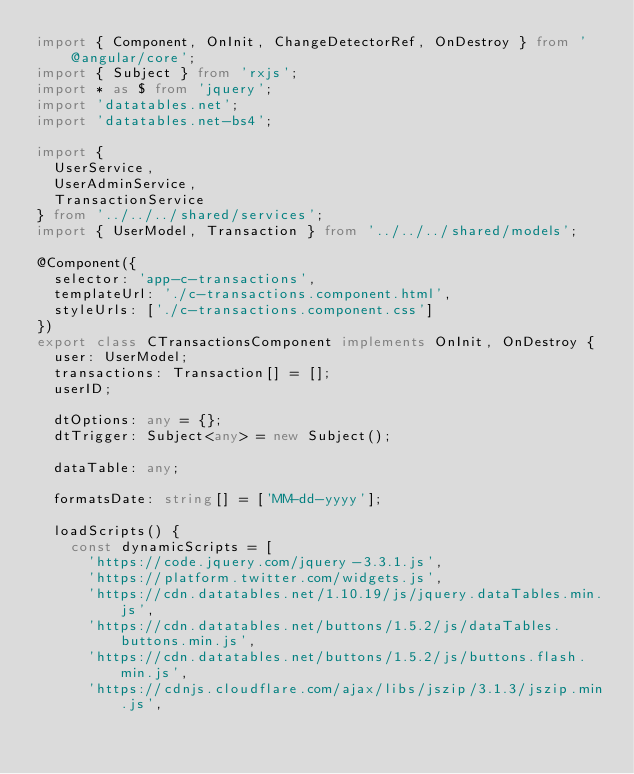Convert code to text. <code><loc_0><loc_0><loc_500><loc_500><_TypeScript_>import { Component, OnInit, ChangeDetectorRef, OnDestroy } from '@angular/core';
import { Subject } from 'rxjs';
import * as $ from 'jquery';
import 'datatables.net';
import 'datatables.net-bs4';

import {
  UserService,
  UserAdminService,
  TransactionService
} from '../../../shared/services';
import { UserModel, Transaction } from '../../../shared/models';

@Component({
  selector: 'app-c-transactions',
  templateUrl: './c-transactions.component.html',
  styleUrls: ['./c-transactions.component.css']
})
export class CTransactionsComponent implements OnInit, OnDestroy {
  user: UserModel;
  transactions: Transaction[] = [];
  userID;

  dtOptions: any = {};
  dtTrigger: Subject<any> = new Subject();

  dataTable: any;

  formatsDate: string[] = ['MM-dd-yyyy'];

  loadScripts() {
    const dynamicScripts = [
      'https://code.jquery.com/jquery-3.3.1.js',
      'https://platform.twitter.com/widgets.js',
      'https://cdn.datatables.net/1.10.19/js/jquery.dataTables.min.js',
      'https://cdn.datatables.net/buttons/1.5.2/js/dataTables.buttons.min.js',
      'https://cdn.datatables.net/buttons/1.5.2/js/buttons.flash.min.js',
      'https://cdnjs.cloudflare.com/ajax/libs/jszip/3.1.3/jszip.min.js',</code> 